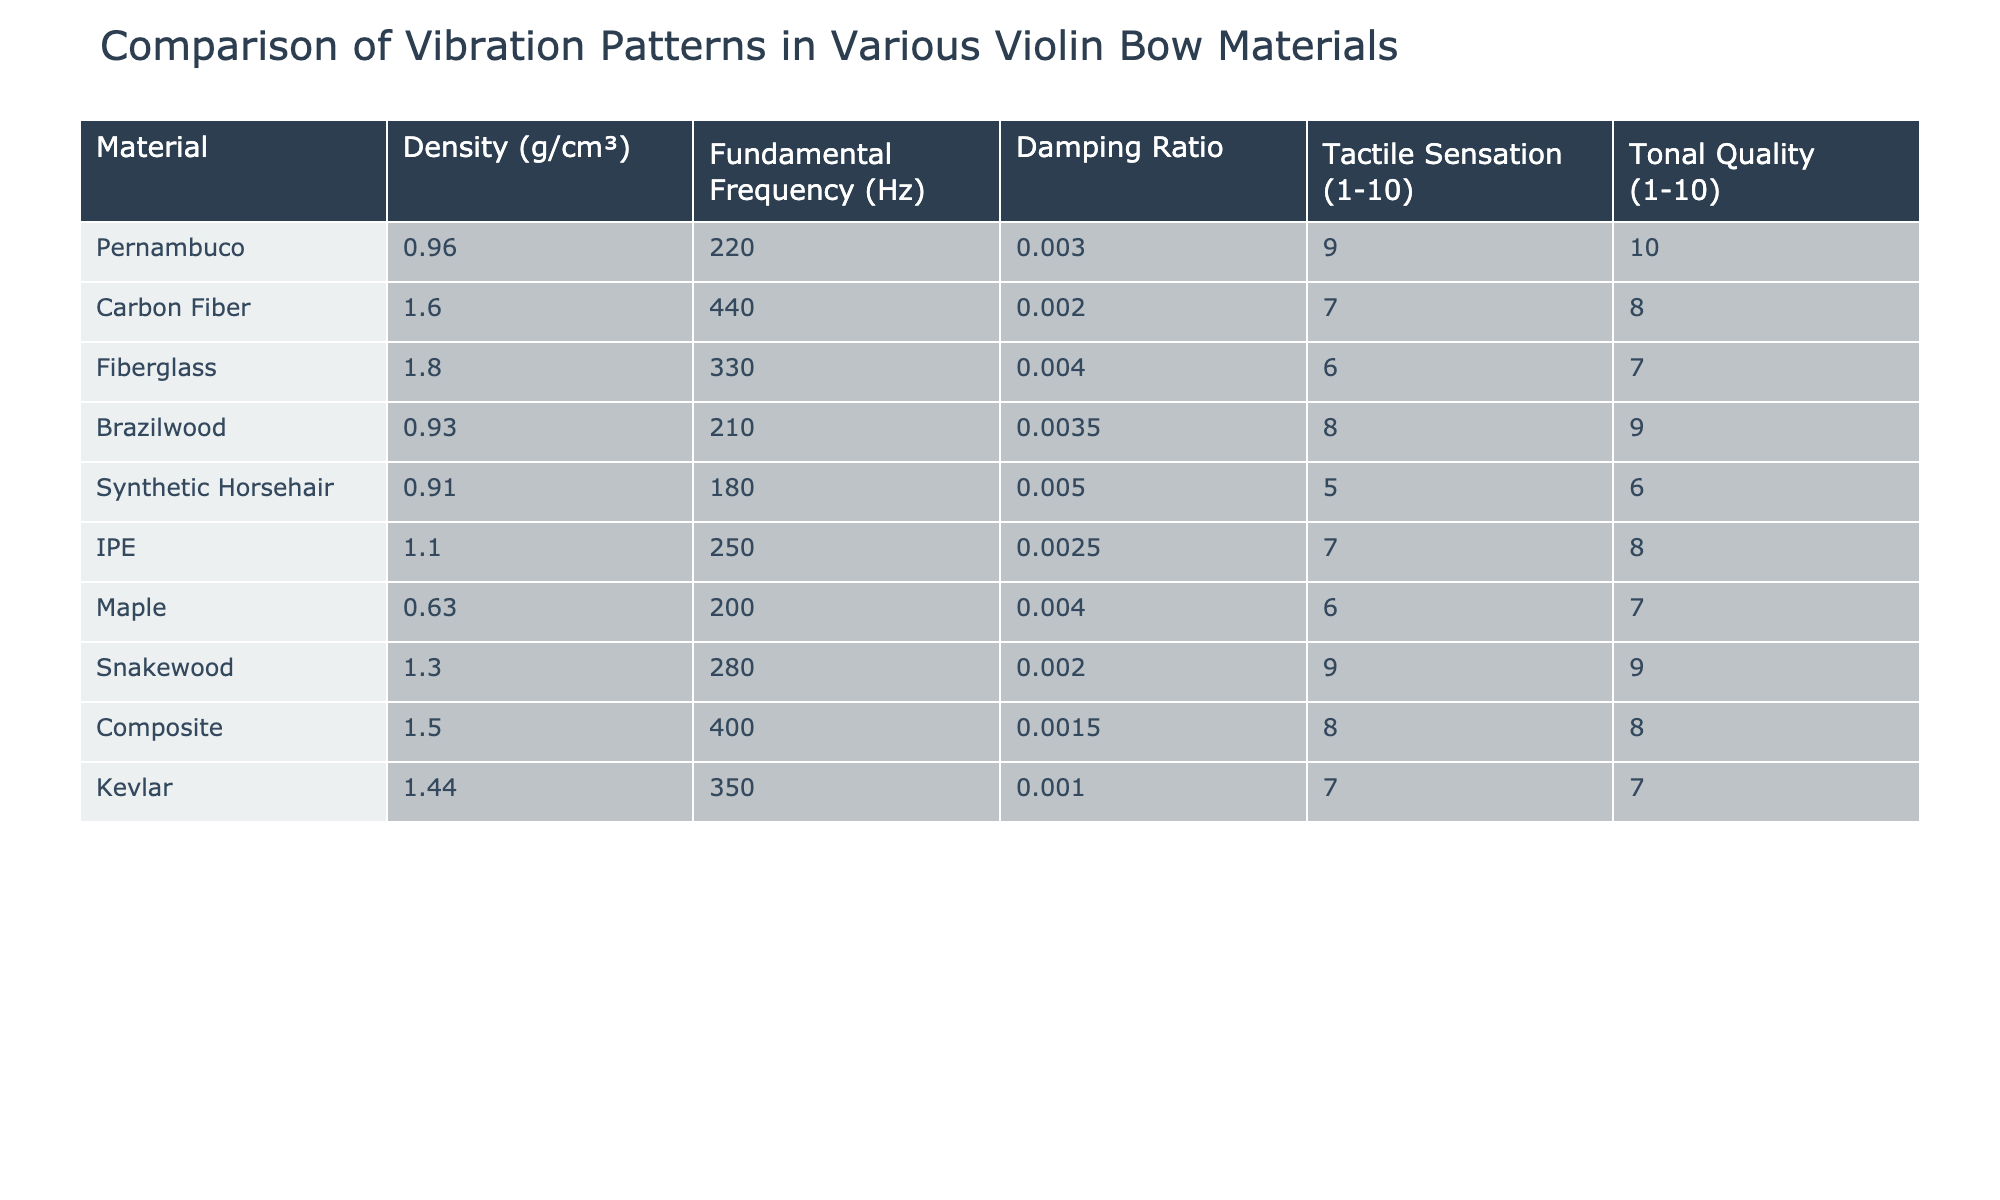What is the fundamental frequency of Pernambuco? The fundamental frequency of Pernambuco is listed in the table under the corresponding column. It shows a value of 220 Hz.
Answer: 220 Hz Which material has the highest damping ratio? Reviewing the damping ratios for each material, Carbon Fiber has the highest value at 0.002.
Answer: Carbon Fiber What is the tonal quality rating of Snakewood? The tonal quality for Snakewood is specified in the table as 9.
Answer: 9 Calculate the average density of all the materials listed. To find the average density, sum all the densities: (0.96 + 1.6 + 1.8 + 0.93 + 0.91 + 1.1 + 0.63 + 1.3 + 1.5 + 1.44) = 12.07. There are 10 materials, so the average is 12.07 / 10 = 1.207.
Answer: 1.207 g/cm³ Is the tactile sensation of Composite higher than that of Kevlar? The tactile sensation of Composite is 8, while Kevlar's tactile sensation is 7. Since 8 is greater than 7, the answer is yes.
Answer: Yes Which bow material offers the best tonal quality? By checking the tonal quality ratings, Pernambuco scores the highest at 10.
Answer: Pernambuco What is the difference in fundamental frequency between Carbon Fiber and Fiberglass? The fundamental frequency of Carbon Fiber is 440 Hz, and for Fiberglass, it is 330 Hz. The difference is 440 - 330 = 110 Hz.
Answer: 110 Hz Which materials have a tactile sensation rating of 7 or higher? Looking at the tactile sensation column, the materials with ratings of 7 or higher are Carbon Fiber, IPE, Snakewood, and Composite.
Answer: Carbon Fiber, IPE, Snakewood, Composite Is the density of Brazilwood less than that of Maple? The density of Brazilwood is 0.93 g/cm³, and Maple's density is 0.63 g/cm³. Since 0.93 is greater than 0.63, the answer is no.
Answer: No Calculate the average tonal quality of the materials. Summing the tonal quality ratings gives us (10 + 8 + 7 + 9 + 6 + 8 + 7 + 9 + 8 + 7) = 79. Dividing by 10 gives an average tonal quality of 79 / 10 = 7.9.
Answer: 7.9 